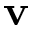Convert formula to latex. <formula><loc_0><loc_0><loc_500><loc_500>\mathbf v</formula> 